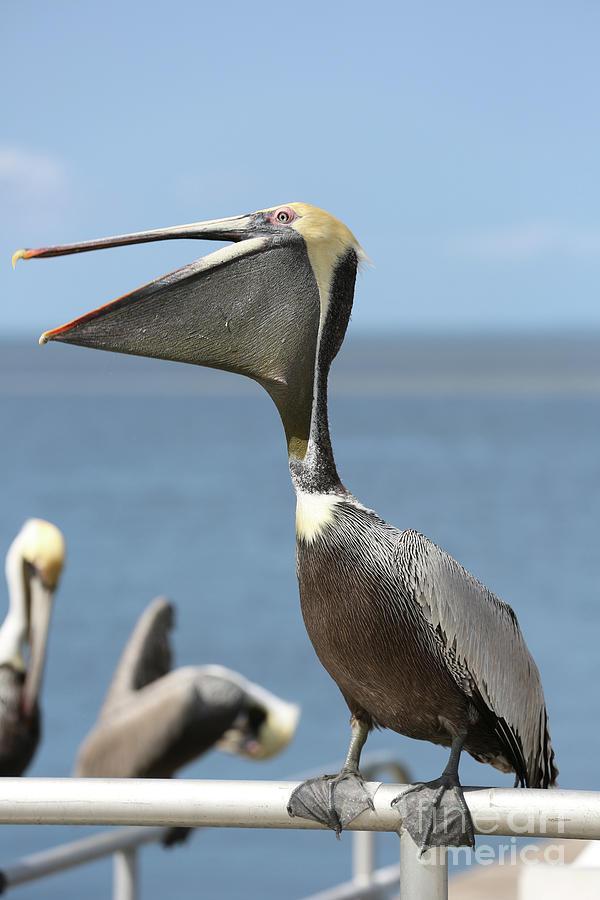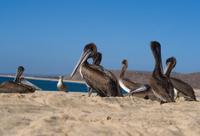The first image is the image on the left, the second image is the image on the right. Assess this claim about the two images: "Left image shows a pelican perched on a structure in the foreground.". Correct or not? Answer yes or no. Yes. The first image is the image on the left, the second image is the image on the right. Evaluate the accuracy of this statement regarding the images: "At least two birds are flying.". Is it true? Answer yes or no. No. 